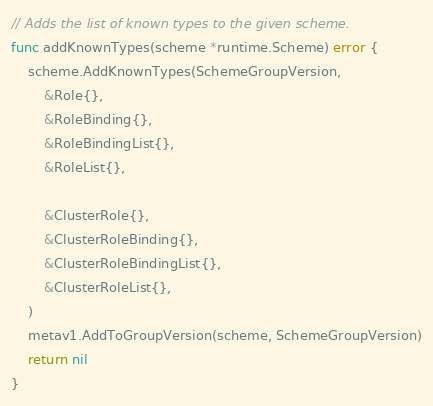Convert code to text. <code><loc_0><loc_0><loc_500><loc_500><_Go_>
// Adds the list of known types to the given scheme.
func addKnownTypes(scheme *runtime.Scheme) error {
	scheme.AddKnownTypes(SchemeGroupVersion,
		&Role{},
		&RoleBinding{},
		&RoleBindingList{},
		&RoleList{},

		&ClusterRole{},
		&ClusterRoleBinding{},
		&ClusterRoleBindingList{},
		&ClusterRoleList{},
	)
	metav1.AddToGroupVersion(scheme, SchemeGroupVersion)
	return nil
}
</code> 